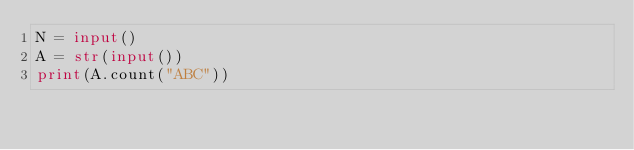Convert code to text. <code><loc_0><loc_0><loc_500><loc_500><_Python_>N = input()
A = str(input())
print(A.count("ABC"))</code> 